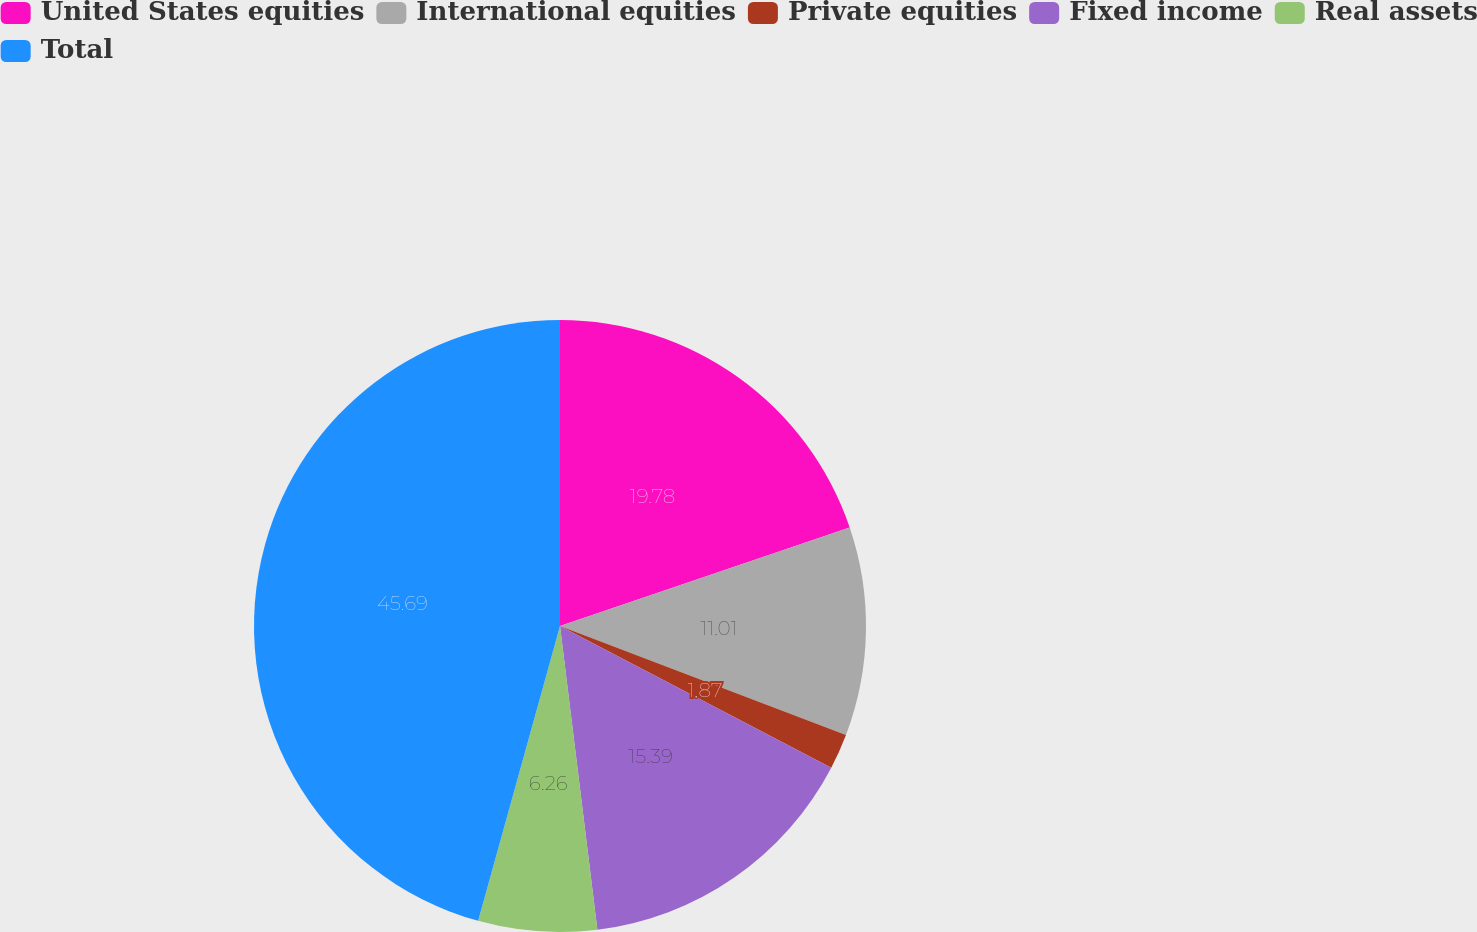Convert chart. <chart><loc_0><loc_0><loc_500><loc_500><pie_chart><fcel>United States equities<fcel>International equities<fcel>Private equities<fcel>Fixed income<fcel>Real assets<fcel>Total<nl><fcel>19.78%<fcel>11.01%<fcel>1.87%<fcel>15.39%<fcel>6.26%<fcel>45.69%<nl></chart> 